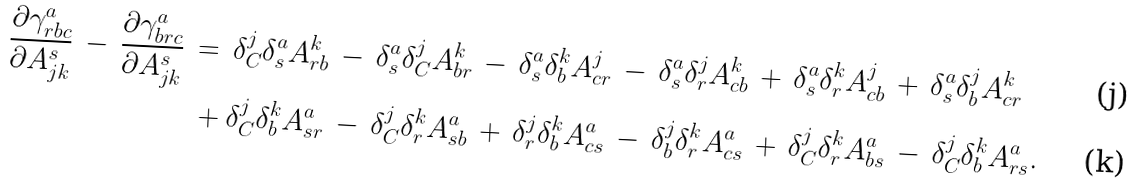Convert formula to latex. <formula><loc_0><loc_0><loc_500><loc_500>\, \frac { \partial \gamma _ { r b c } ^ { a } } { \partial A _ { j k } ^ { s } } \, - \, \frac { \partial \gamma _ { b r c } ^ { a } } { \partial A _ { j k } ^ { s } } \, & = \, \delta _ { C } ^ { j } \delta _ { s } ^ { a } A _ { r b } ^ { k } \, - \, \delta _ { s } ^ { a } \delta _ { C } ^ { j } A _ { b r } ^ { k } \, - \, \delta _ { s } ^ { a } \delta _ { b } ^ { k } A _ { c r } ^ { j } \, - \, \delta _ { s } ^ { a } \delta _ { r } ^ { j } A _ { c b } ^ { k } \, + \, \delta _ { s } ^ { a } \delta _ { r } ^ { k } A _ { c b } ^ { j } \, + \, \delta _ { s } ^ { a } \delta _ { b } ^ { j } A _ { c r } ^ { k } \\ & \, + \delta _ { C } ^ { j } \delta _ { b } ^ { k } A _ { s r } ^ { a } \, - \, \delta _ { C } ^ { j } \delta _ { r } ^ { k } A _ { s b } ^ { a } \, + \, \delta _ { r } ^ { j } \delta _ { b } ^ { k } A _ { c s } ^ { a } \, - \, \delta _ { b } ^ { j } \delta _ { r } ^ { k } A _ { c s } ^ { a } \, + \, \delta _ { C } ^ { j } \delta _ { r } ^ { k } A _ { b s } ^ { a } \, - \, \delta _ { C } ^ { j } \delta _ { b } ^ { k } A _ { r s } ^ { a } .</formula> 